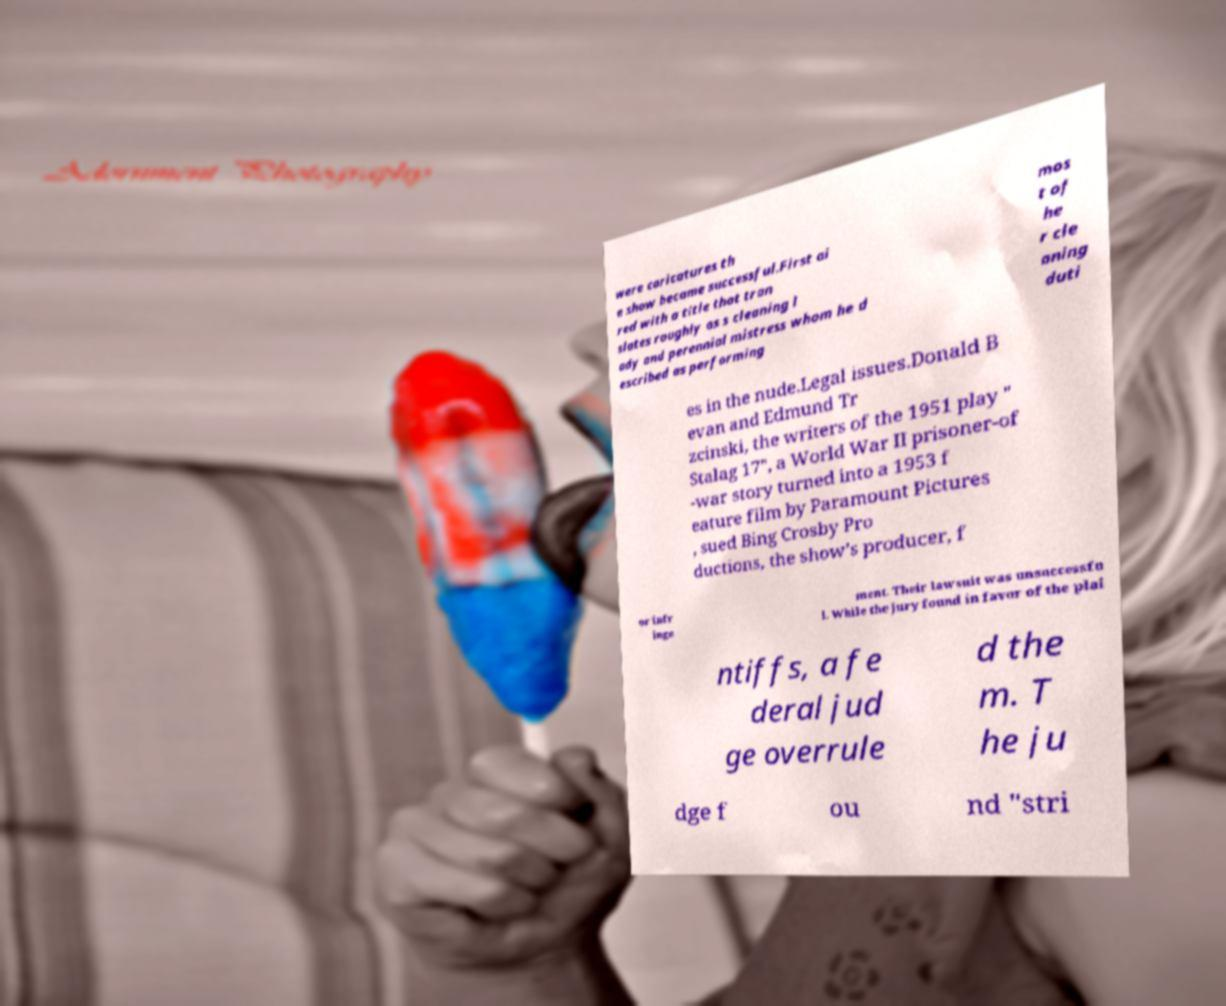For documentation purposes, I need the text within this image transcribed. Could you provide that? were caricatures th e show became successful.First ai red with a title that tran slates roughly as s cleaning l ady and perennial mistress whom he d escribed as performing mos t of he r cle aning duti es in the nude.Legal issues.Donald B evan and Edmund Tr zcinski, the writers of the 1951 play " Stalag 17", a World War II prisoner-of -war story turned into a 1953 f eature film by Paramount Pictures , sued Bing Crosby Pro ductions, the show’s producer, f or infr inge ment. Their lawsuit was unsuccessfu l. While the jury found in favor of the plai ntiffs, a fe deral jud ge overrule d the m. T he ju dge f ou nd "stri 